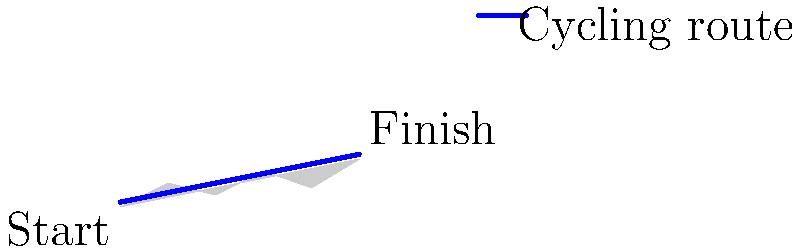As a sports journalist writing about Andy Hampsten's career, you come across an aerial image of a cycling race route. Based on the terrain profile and route characteristics shown in the image, which famous cycling race is this most likely to represent? To identify the cycling race route from the aerial imagery, let's analyze the key features:

1. Terrain profile: The image shows a mountainous terrain with significant elevation changes. This suggests a race that includes mountain stages.

2. Route characteristics: The path is relatively straightforward without many sharp turns, indicating a point-to-point race rather than a circuit.

3. Length: The route appears to cover a considerable distance, spanning the entire width of the image.

4. Elevation gain: There's a notable net elevation gain from start to finish, with the finish line at a higher elevation than the start.

5. Andy Hampsten connection: As we're writing about Andy Hampsten, we should consider races where he had significant achievements.

Given these observations, the most likely race this represents is the Giro d'Italia, specifically the 1988 edition. Andy Hampsten is famous for his performance in this race, particularly on the Gavia Pass stage, which featured similar mountainous terrain and elevation gain.

The 1988 Giro d'Italia included several challenging mountain stages in the Dolomites and Alps, which aligns with the terrain shown in the image. Hampsten's victory in this race, particularly his performance in difficult mountain stages, was a defining moment in his career.

While other races like the Tour de France also feature mountain stages, Hampsten's most significant career achievement was winning the 1988 Giro d'Italia, making this the most likely answer given the context of writing about his career.
Answer: 1988 Giro d'Italia 